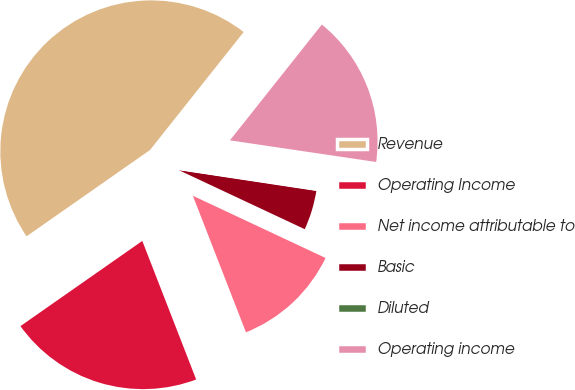<chart> <loc_0><loc_0><loc_500><loc_500><pie_chart><fcel>Revenue<fcel>Operating Income<fcel>Net income attributable to<fcel>Basic<fcel>Diluted<fcel>Operating income<nl><fcel>45.39%<fcel>21.19%<fcel>12.12%<fcel>4.59%<fcel>0.05%<fcel>16.66%<nl></chart> 